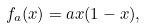Convert formula to latex. <formula><loc_0><loc_0><loc_500><loc_500>f _ { a } ( x ) = a x ( 1 - x ) ,</formula> 